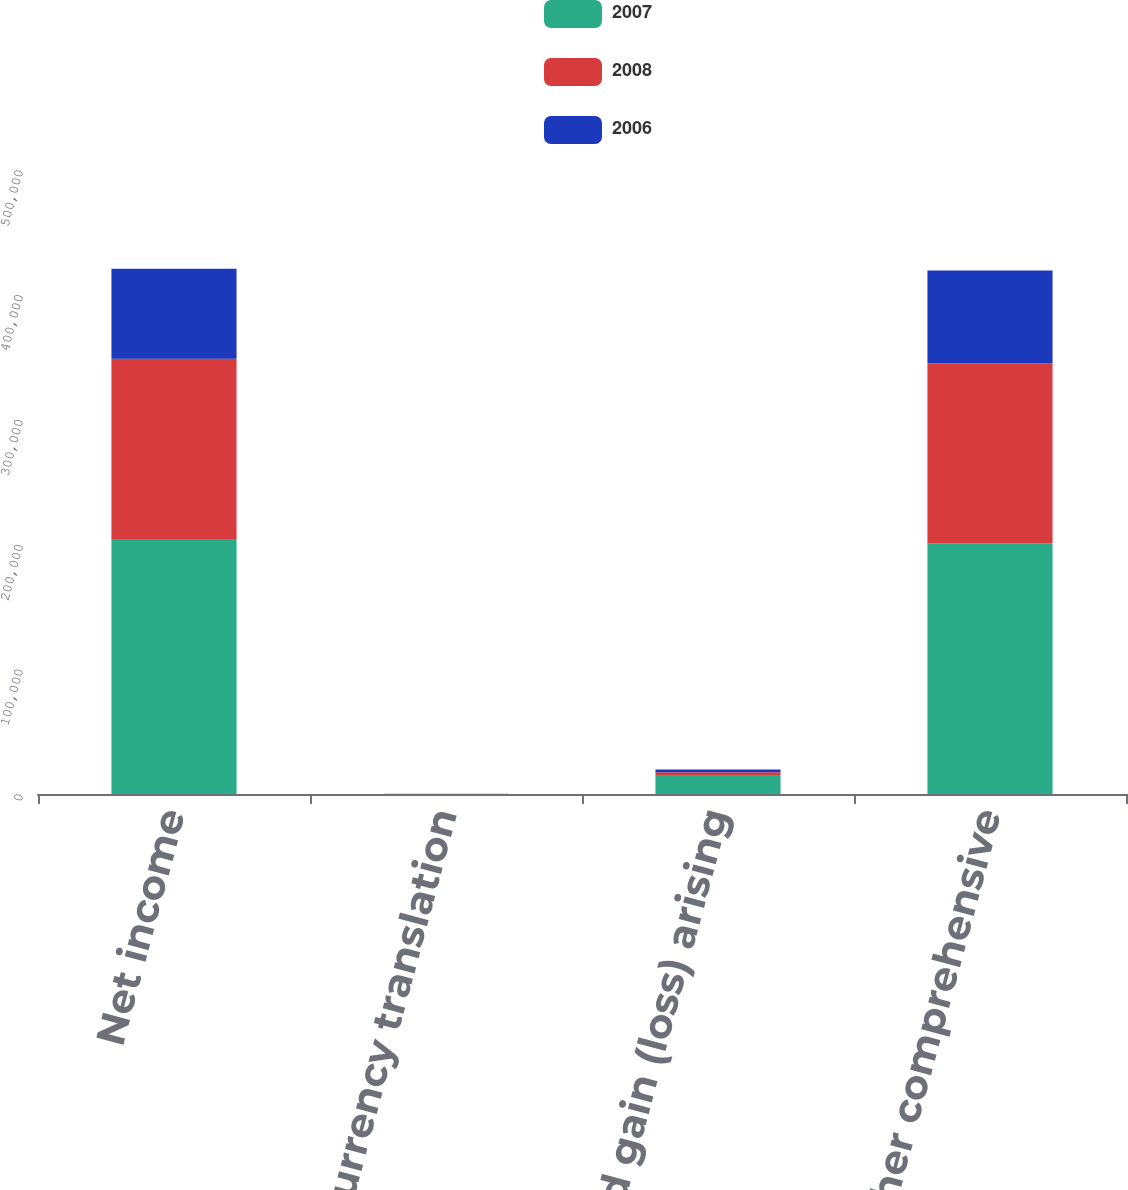Convert chart to OTSL. <chart><loc_0><loc_0><loc_500><loc_500><stacked_bar_chart><ecel><fcel>Net income<fcel>Foreign currency translation<fcel>Unrealized gain (loss) arising<fcel>Total other comprehensive<nl><fcel>2007<fcel>204315<fcel>109<fcel>15187<fcel>200842<nl><fcel>2008<fcel>144537<fcel>12<fcel>2258<fcel>144362<nl><fcel>2006<fcel>72044<fcel>22<fcel>2160<fcel>74226<nl></chart> 